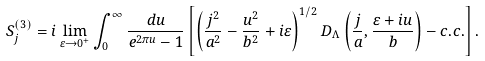<formula> <loc_0><loc_0><loc_500><loc_500>S _ { j } ^ { ( 3 ) } = i \lim _ { \varepsilon \to 0 ^ { + } } \int _ { 0 } ^ { \infty } \frac { d u } { e ^ { 2 \pi u } - 1 } \left [ \left ( \frac { j ^ { 2 } } { a ^ { 2 } } - \frac { u ^ { 2 } } { b ^ { 2 } } + i \varepsilon \right ) ^ { 1 / 2 } D _ { \Lambda } \left ( \frac { j } { a } , \frac { \varepsilon + i u } { b } \right ) - c . c . \right ] .</formula> 